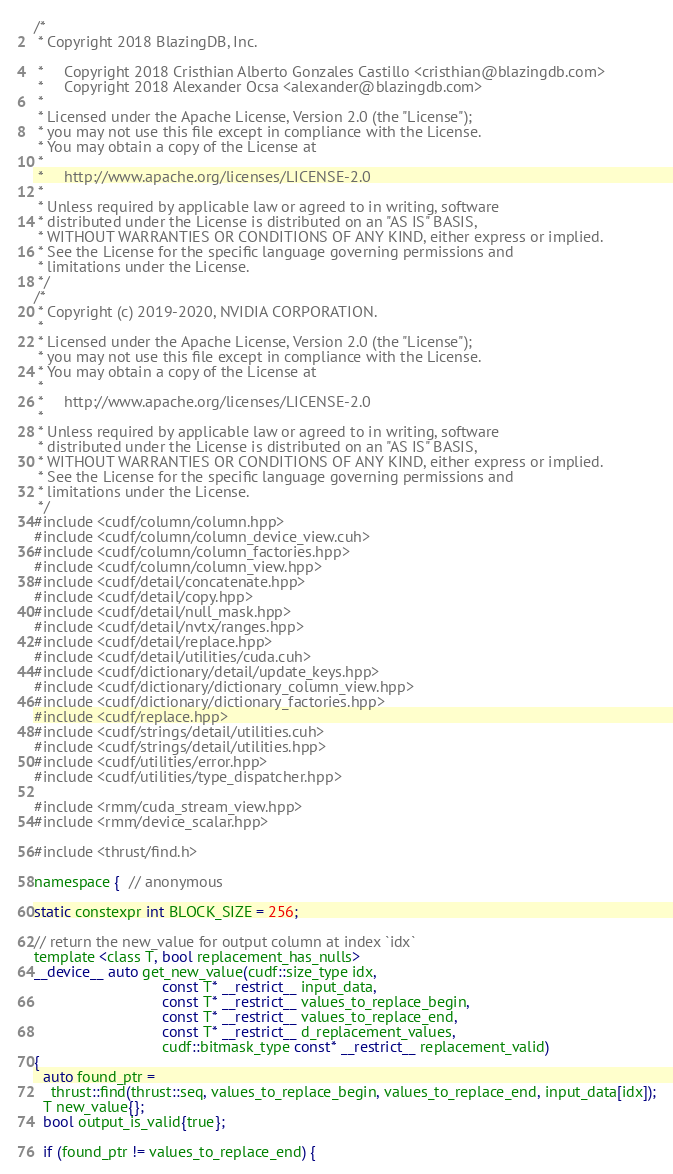<code> <loc_0><loc_0><loc_500><loc_500><_Cuda_>/*
 * Copyright 2018 BlazingDB, Inc.

 *     Copyright 2018 Cristhian Alberto Gonzales Castillo <cristhian@blazingdb.com>
 *     Copyright 2018 Alexander Ocsa <alexander@blazingdb.com>
 *
 * Licensed under the Apache License, Version 2.0 (the "License");
 * you may not use this file except in compliance with the License.
 * You may obtain a copy of the License at
 *
 *     http://www.apache.org/licenses/LICENSE-2.0
 *
 * Unless required by applicable law or agreed to in writing, software
 * distributed under the License is distributed on an "AS IS" BASIS,
 * WITHOUT WARRANTIES OR CONDITIONS OF ANY KIND, either express or implied.
 * See the License for the specific language governing permissions and
 * limitations under the License.
 */
/*
 * Copyright (c) 2019-2020, NVIDIA CORPORATION.
 *
 * Licensed under the Apache License, Version 2.0 (the "License");
 * you may not use this file except in compliance with the License.
 * You may obtain a copy of the License at
 *
 *     http://www.apache.org/licenses/LICENSE-2.0
 *
 * Unless required by applicable law or agreed to in writing, software
 * distributed under the License is distributed on an "AS IS" BASIS,
 * WITHOUT WARRANTIES OR CONDITIONS OF ANY KIND, either express or implied.
 * See the License for the specific language governing permissions and
 * limitations under the License.
 */
#include <cudf/column/column.hpp>
#include <cudf/column/column_device_view.cuh>
#include <cudf/column/column_factories.hpp>
#include <cudf/column/column_view.hpp>
#include <cudf/detail/concatenate.hpp>
#include <cudf/detail/copy.hpp>
#include <cudf/detail/null_mask.hpp>
#include <cudf/detail/nvtx/ranges.hpp>
#include <cudf/detail/replace.hpp>
#include <cudf/detail/utilities/cuda.cuh>
#include <cudf/dictionary/detail/update_keys.hpp>
#include <cudf/dictionary/dictionary_column_view.hpp>
#include <cudf/dictionary/dictionary_factories.hpp>
#include <cudf/replace.hpp>
#include <cudf/strings/detail/utilities.cuh>
#include <cudf/strings/detail/utilities.hpp>
#include <cudf/utilities/error.hpp>
#include <cudf/utilities/type_dispatcher.hpp>

#include <rmm/cuda_stream_view.hpp>
#include <rmm/device_scalar.hpp>

#include <thrust/find.h>

namespace {  // anonymous

static constexpr int BLOCK_SIZE = 256;

// return the new_value for output column at index `idx`
template <class T, bool replacement_has_nulls>
__device__ auto get_new_value(cudf::size_type idx,
                              const T* __restrict__ input_data,
                              const T* __restrict__ values_to_replace_begin,
                              const T* __restrict__ values_to_replace_end,
                              const T* __restrict__ d_replacement_values,
                              cudf::bitmask_type const* __restrict__ replacement_valid)
{
  auto found_ptr =
    thrust::find(thrust::seq, values_to_replace_begin, values_to_replace_end, input_data[idx]);
  T new_value{};
  bool output_is_valid{true};

  if (found_ptr != values_to_replace_end) {</code> 